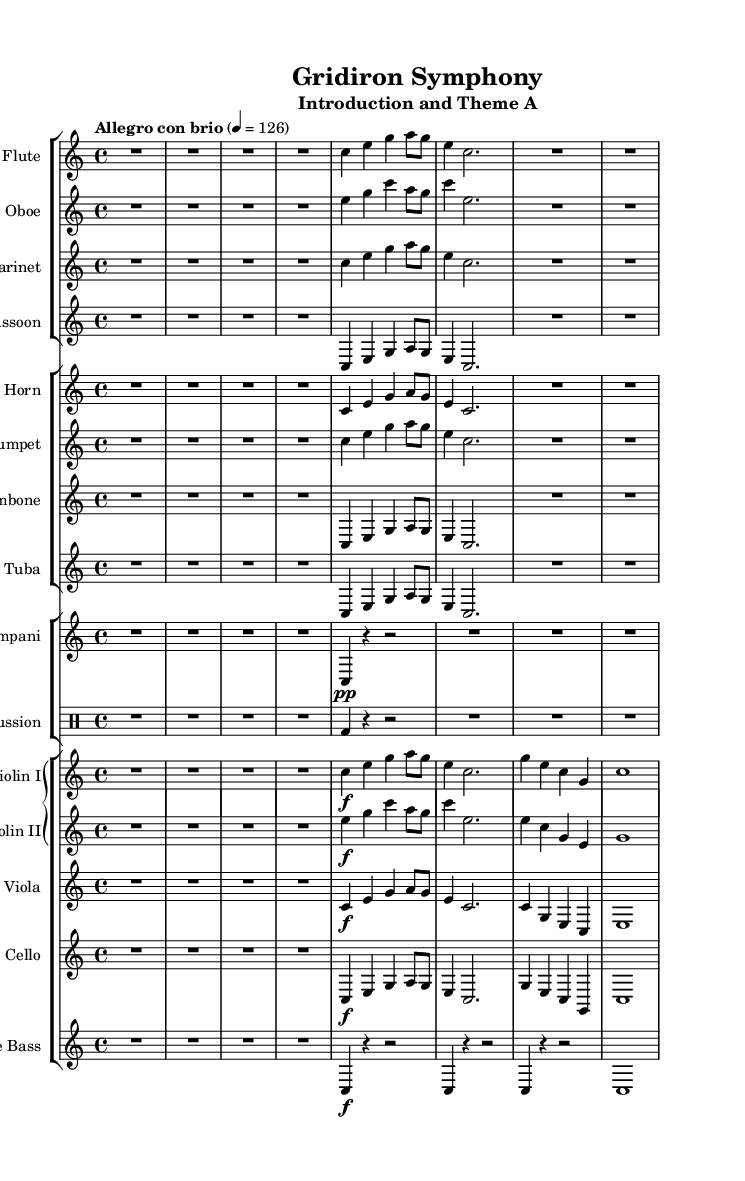What is the key signature of this music? The key signature is C major, which has no sharps or flats.
Answer: C major What is the time signature of the piece? The time signature is shown as 4/4, indicating four beats per measure.
Answer: 4/4 What tempo marking is indicated for the piece? The tempo marking of "Allegro con brio" indicates a lively and brisk tempo, supported with a metronome mark of 126 beats per minute.
Answer: Allegro con brio How many measure rests are indicated for the flute at the beginning? The flute has a quarter note rest for the first measure and continues after that, making it one measure rest before playing.
Answer: 1 measure What is the highest note played by the violin I in the excerpt? The highest note in the excerpt played by violin I is G5, which is present in the third measure as indicated by the notation.
Answer: G Which instruments hold the primary melody in this section? The primary melody is typically carried by the flute and violin I sections, where they introduce the main thematic material.
Answer: Flute and Violin I What dynamic marking is observed at the beginning for the violins? The violins have a dynamic marking of forte, indicated by the 'f' in the sheet music, calling for a strong and loud sound.
Answer: forte 